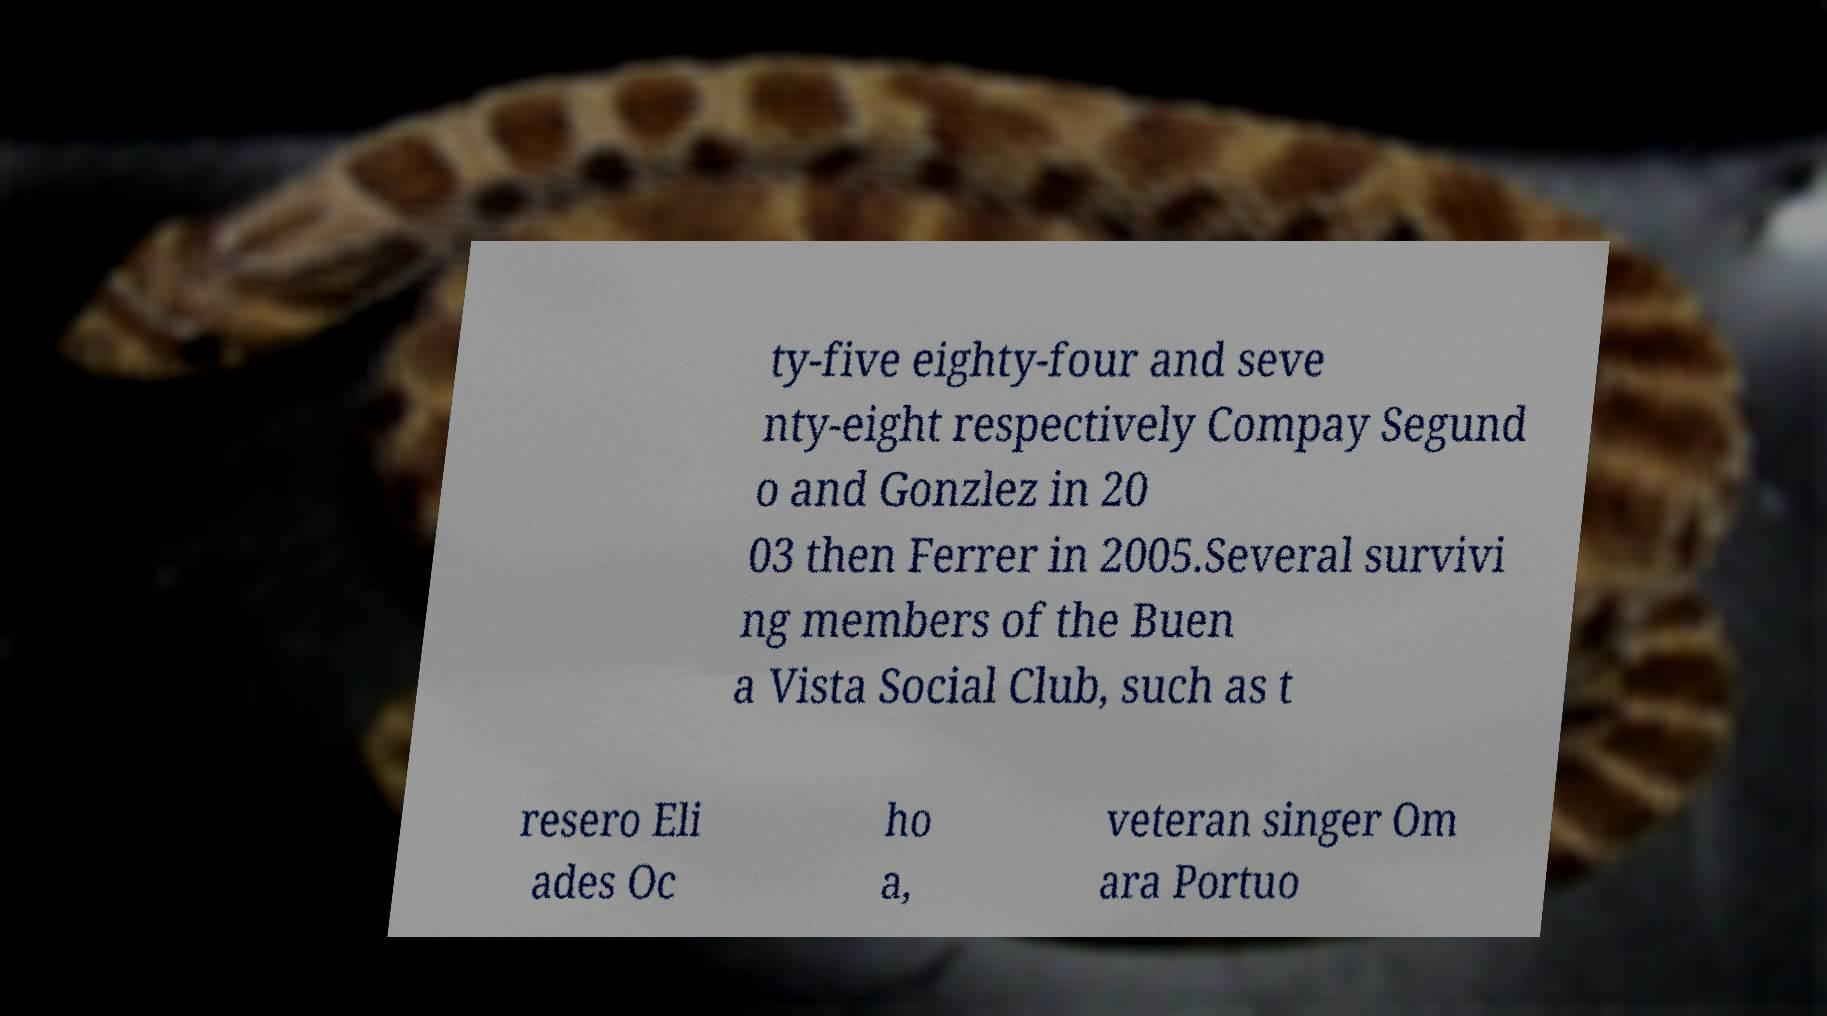I need the written content from this picture converted into text. Can you do that? ty-five eighty-four and seve nty-eight respectively Compay Segund o and Gonzlez in 20 03 then Ferrer in 2005.Several survivi ng members of the Buen a Vista Social Club, such as t resero Eli ades Oc ho a, veteran singer Om ara Portuo 